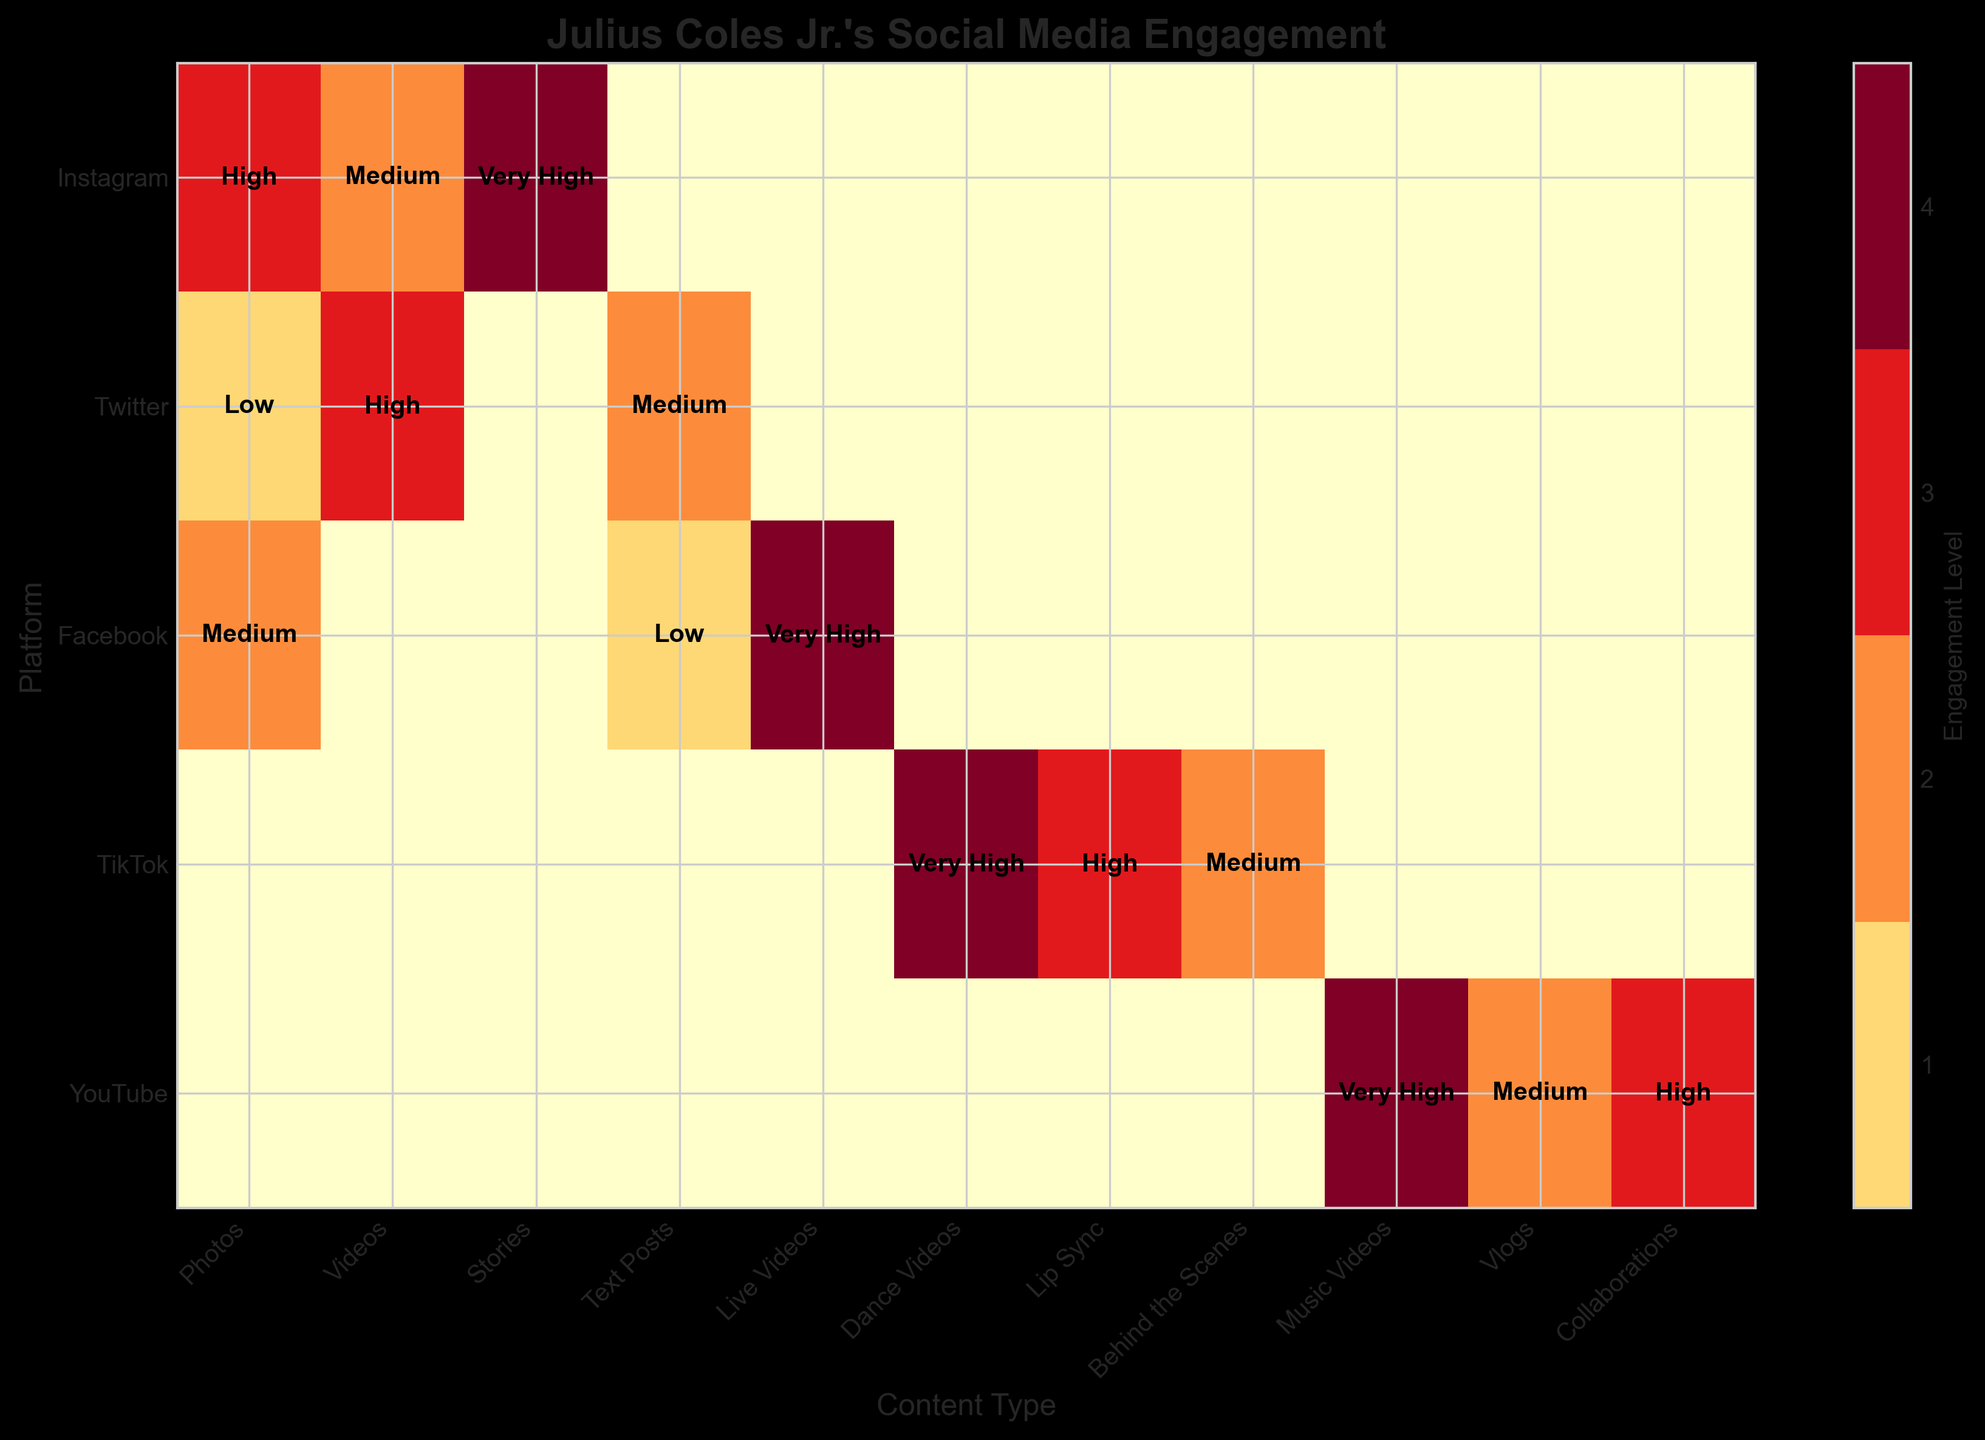What is the title of the figure? The title is typically located at the top of a figure. Here, it states, "Julius Coles Jr.'s Social Media Engagement".
Answer: Julius Coles Jr.'s Social Media Engagement Which platform shows a 'Very High' engagement level for 'Stories'? Look for the intersection of the 'Instagram' row and the 'Stories' column and note the engagement level.
Answer: Instagram How does the engagement level of 'Photos' on Twitter compare to that on Instagram? Compare the engagement levels of 'Photos' in the 'Twitter' row and the 'Instagram' row. Twitter shows 'Low' while Instagram shows 'High'.
Answer: Instagram is higher than Twitter Which content type on TikTok has the highest engagement level? Look at the 'TikTok' row and find the highest engagement level. The 'Dance Videos' column is marked as 'Very High'.
Answer: Dance Videos What content type is associated with the highest engagement level on Facebook? Find the highest engagement level in the 'Facebook' row. The 'Live Videos' column shows 'Very High'.
Answer: Live Videos Which platform has the most diverse engagement levels across different content types? Look for a platform row that shows a broad range of engagement levels. 'Facebook' presents 'Very High', 'Medium', and 'Low' indicating more diversity compared to others.
Answer: Facebook How many platforms have 'Very High' engagement levels in at least one content type? Count the number of platform rows that have at least one 'Very High' engagement level. Instagram, Facebook, TikTok, and YouTube all have at least one 'Very High'.
Answer: Four What is the engagement level of 'Text Posts' on Facebook? Find the intersection of the 'Facebook' row and the 'Text Posts' column and note the engagement level.
Answer: Low How do the 'Medium' engagement levels on TikTok compare to YouTube's 'Medium' engagement levels? Compare the number of 'Medium' levels in the 'TikTok' row (one) to the 'YouTube' row (one).
Answer: Both have one 'Medium' Which content type shows a 'High' engagement level both on Twitter and YouTube? Look at the engagement levels for both 'Twitter' and 'YouTube' rows and find the content type with 'High' levels. 'Videos' in Twitter and 'Collaborations' in YouTube.
Answer: Different content types ('Videos' for Twitter, 'Collaborations' for YouTube) 